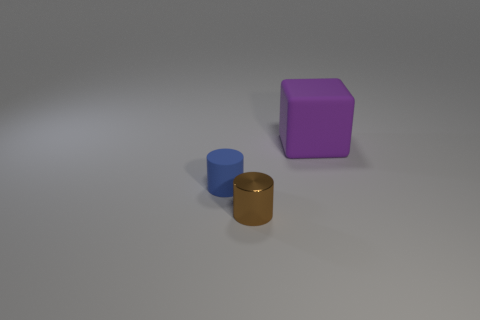What objects are displayed in the image and what could their potential uses be? The image shows three objects on a flat surface: a small blue cylinder, a golden cylinder, and a purple cube. The blue cylinder could be a container or a base for a small item, the golden cylinder might serve as a pencil holder or a decorative element, and the purple cube could be a child's toy, a paperweight, or part of a modular storage system. 